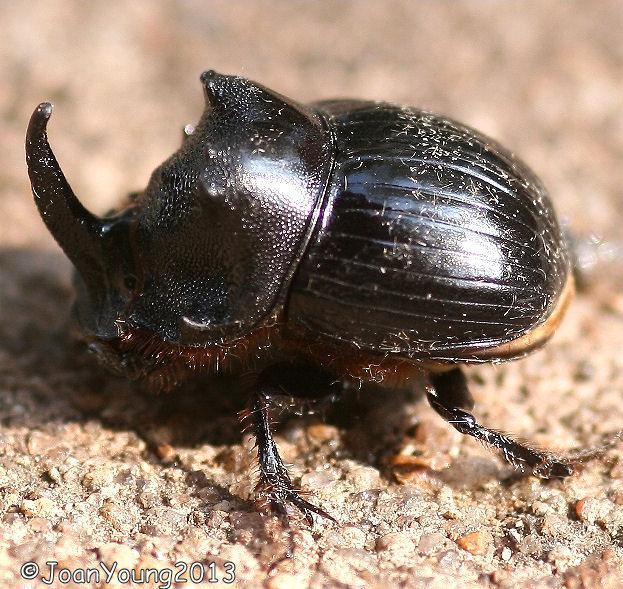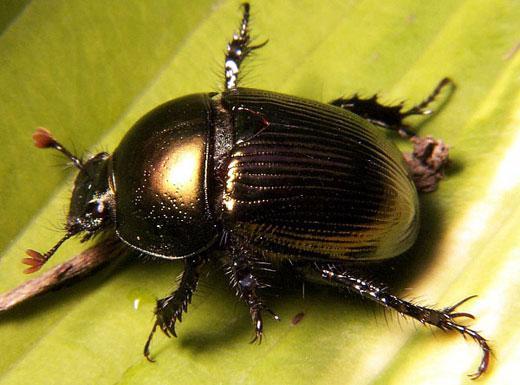The first image is the image on the left, the second image is the image on the right. Examine the images to the left and right. Is the description "There are two insects touching the ball in the image on the right" accurate? Answer yes or no. No. The first image is the image on the left, the second image is the image on the right. Given the left and right images, does the statement "Left image shows one left-facing beetle with no dungball." hold true? Answer yes or no. Yes. 